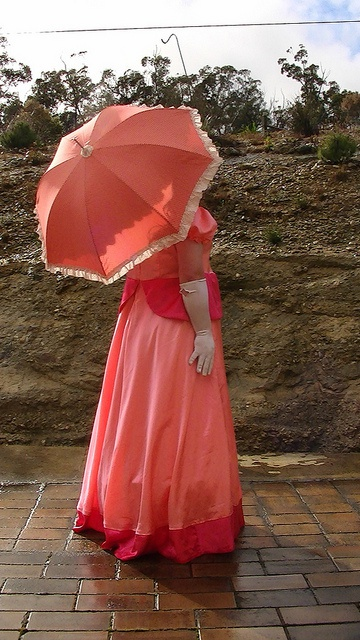Describe the objects in this image and their specific colors. I can see people in white, brown, and salmon tones and umbrella in white, brown, and salmon tones in this image. 